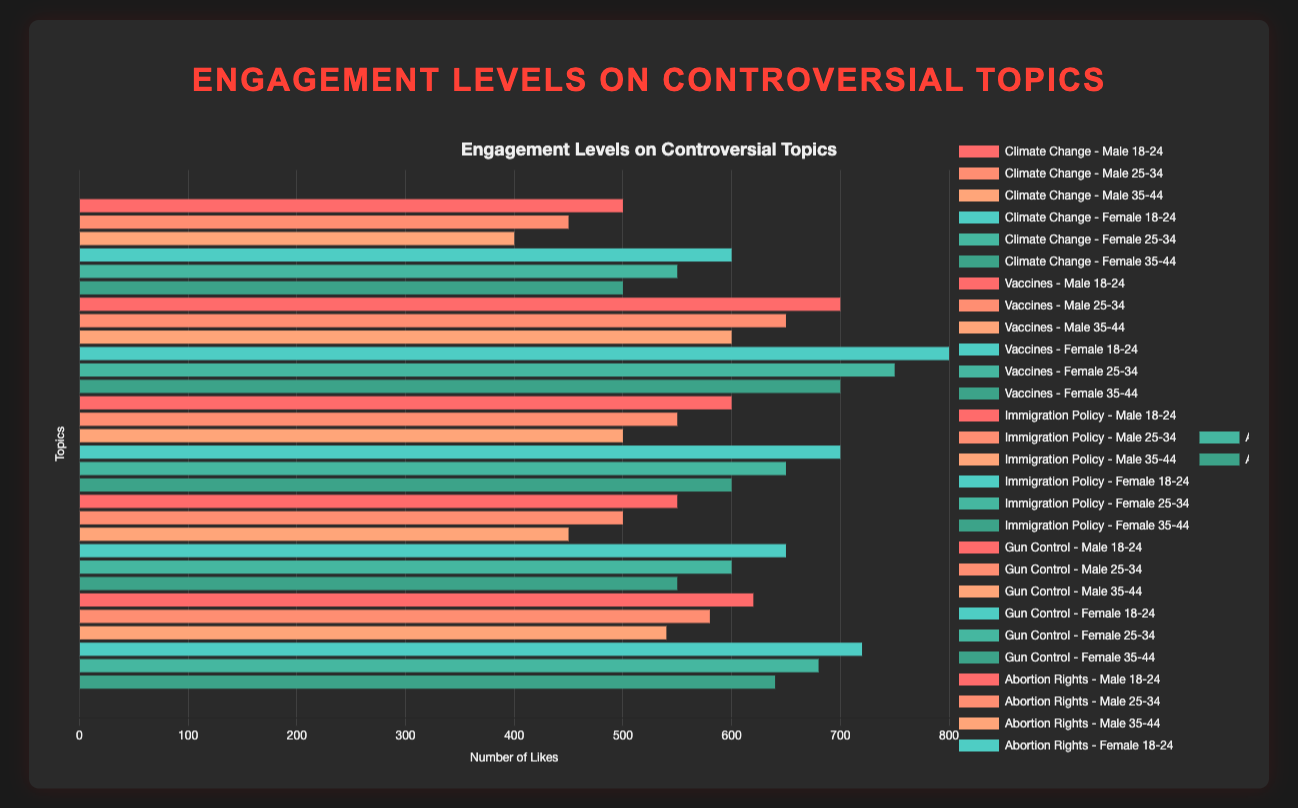Which age group shows the highest likes on Climate Change posts? Refer to the bars representing likes for each age group on Climate Change posts. The highest likes for Climate Change are shown by the group "Female 18-24" with 600 likes.
Answer: Female 18-24 Which topic has more likes from males aged 18-24: Climate Change or Vaccines? Compare the likes for males aged 18-24 on both topics. For Climate Change, there are 500 likes; for Vaccines, there are 700 likes. Therefore, Vaccines have more likes.
Answer: Vaccines Among the topics listed, which age group of females consistently shows higher engagement across all topics in terms of likes? Look at the female bars for all age groups across all topics. Notice that for each topic, the "Female 18-24" age group has higher likes consistently.
Answer: Female 18-24 What is the combined total of comments for males aged 25-34 across all topics? Sum the comments for males aged 25-34 for each topic: (60 + 120 + 80 + 70 + 95) which equals 425 comments.
Answer: 425 Which topic and gender combination has the highest number of shares for the age group 18-24? Look at the values for shares for the age group 18-24 for all topics and genders. Females discussing Vaccines have the highest number of shares with 130.
Answer: Vaccines, Female For the topic of Gun Control, which gender and age group combination has the least engagement in terms of comments? Examine the comments for Gun Control across all gender and age group combinations. Males aged 35-44 have the least engagement with 60 comments.
Answer: Male 35-44 